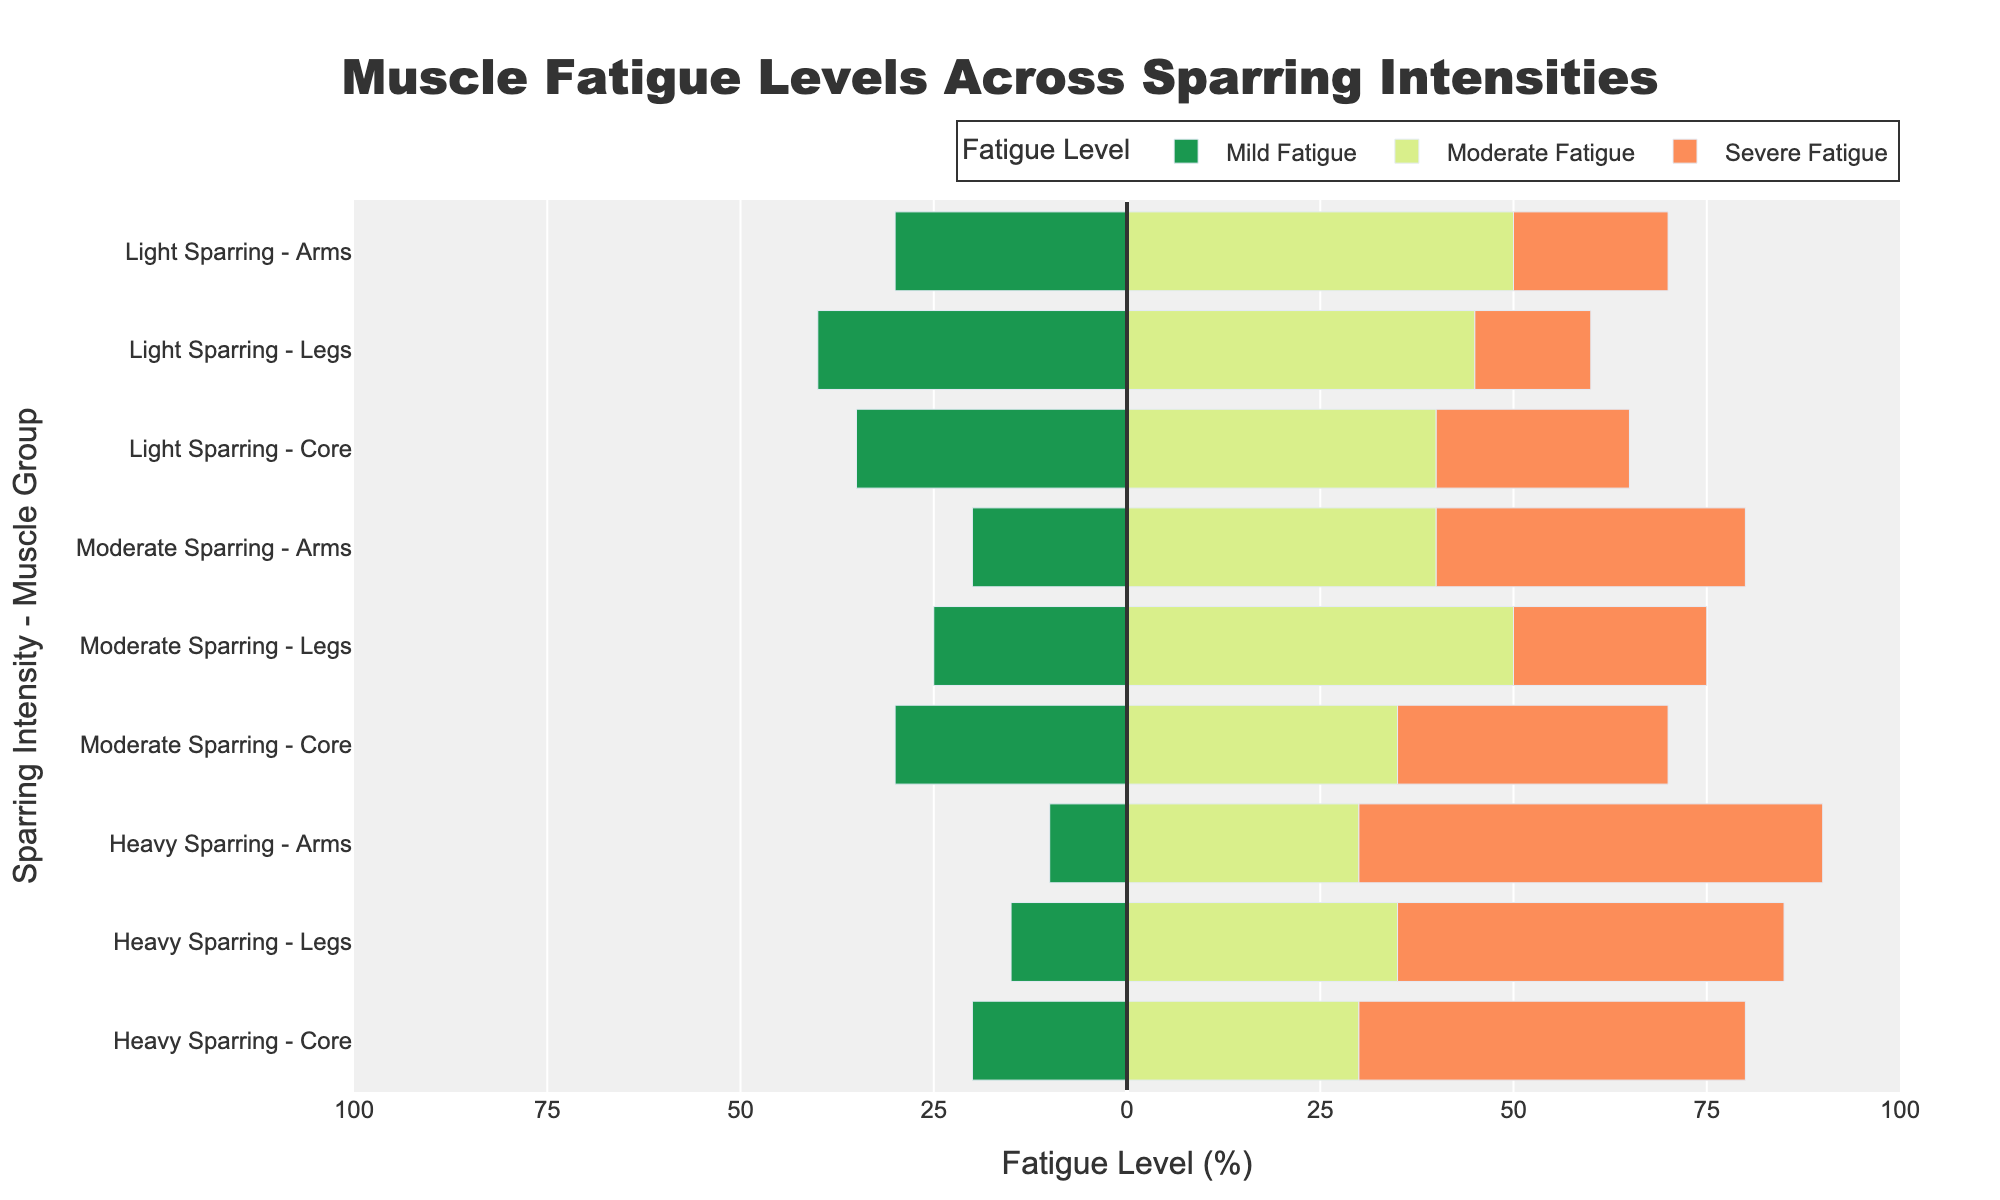Which sparring intensity and muscle group has the highest level of severe fatigue? By looking at the length of the bars for severe fatigue (depicted in a specific color), we can see that Heavy Sparring - Arms has the longest bar, indicating the highest level of severe fatigue at 60%.
Answer: Heavy Sparring - Arms Which muscle group experiences the highest proportion of moderate fatigue during Light Sparring? By examining the bars corresponding to moderate fatigue (mid-length bars), it is visible that the Arms muscle group during Light Sparring has the highest proportion of moderate fatigue at 50%.
Answer: Arms What is the combined percentage of mild fatigue for all muscle groups during Moderate Sparring? Sum the percentages for mild fatigue across all muscle groups during Moderate Sparring: Arms (20%), Legs (25%), Core (30%), giving a total of 20 + 25 + 30 = 75%.
Answer: 75% Compare the severe fatigue levels of Legs during Light Sparring and Heavy Sparring. Which one is higher and by how much? The severe fatigue level for Legs during Light Sparring is 15% and for Heavy Sparring is 50%. The difference is 50 - 15 = 35%, with Heavy Sparring - Legs showing 35% more severe fatigue.
Answer: 35% Which intensity level and muscle group combination shows the least mild fatigue, and what is its percentage? By identifying the shortest bar representing mild fatigue level, Heavy Sparring - Arms show the least mild fatigue at 10%.
Answer: Heavy Sparring - Arms For the Core muscle group, how does the percent of severe fatigue change from Light Sparring to Heavy Sparring? Compare the severe fatigue percentage for the Core muscle group from Light Sparring (25%) to Heavy Sparring (50%). The change is 50 - 25 = 25% increase.
Answer: 25% increase What is the total percentage of all fatigue levels for Legs during Heavy Sparring? Sum the percentages of mild, moderate, and severe fatigue for Legs during Heavy Sparring: 15% + 35% + 50% = 100%.
Answer: 100% Which sparring intensity has the most balanced distribution of fatigue levels for a specific muscle group? Look at the percentages of mild, moderate, and severe fatigue levels that are closest in value. Moderate Sparring - Arms has 20% mild, 40% moderate, and 40% severe fatigue, indicating a more balanced distribution.
Answer: Moderate Sparring - Arms Compare the proportion of moderate fatigue for the Core muscle group across all sparring intensities. Which sparring intensity shows the highest? The proportions of moderate fatigue for Core are: Light Sparring (40%), Moderate Sparring (35%), Heavy Sparring (30%). The highest percentage is for Light Sparring.
Answer: Light Sparring For Heavy Sparring, which muscle group shows the smallest difference between mild and moderate fatigue levels? Find the difference for each muscle group in Heavy Sparring: Arms (30% - 10% = 20%), Legs (35% - 15% = 20%), Core (30% - 20% = 10%). Thus, Core shows the smallest difference.
Answer: Core 